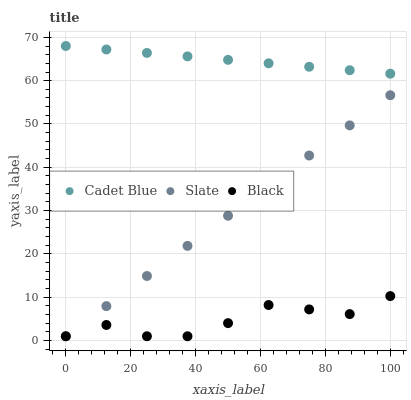Does Black have the minimum area under the curve?
Answer yes or no. Yes. Does Cadet Blue have the maximum area under the curve?
Answer yes or no. Yes. Does Cadet Blue have the minimum area under the curve?
Answer yes or no. No. Does Black have the maximum area under the curve?
Answer yes or no. No. Is Slate the smoothest?
Answer yes or no. Yes. Is Black the roughest?
Answer yes or no. Yes. Is Cadet Blue the smoothest?
Answer yes or no. No. Is Cadet Blue the roughest?
Answer yes or no. No. Does Slate have the lowest value?
Answer yes or no. Yes. Does Cadet Blue have the lowest value?
Answer yes or no. No. Does Cadet Blue have the highest value?
Answer yes or no. Yes. Does Black have the highest value?
Answer yes or no. No. Is Slate less than Cadet Blue?
Answer yes or no. Yes. Is Cadet Blue greater than Black?
Answer yes or no. Yes. Does Black intersect Slate?
Answer yes or no. Yes. Is Black less than Slate?
Answer yes or no. No. Is Black greater than Slate?
Answer yes or no. No. Does Slate intersect Cadet Blue?
Answer yes or no. No. 